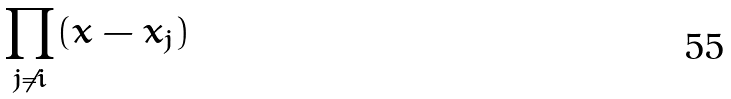Convert formula to latex. <formula><loc_0><loc_0><loc_500><loc_500>\prod _ { j \ne i } ( x - x _ { j } )</formula> 